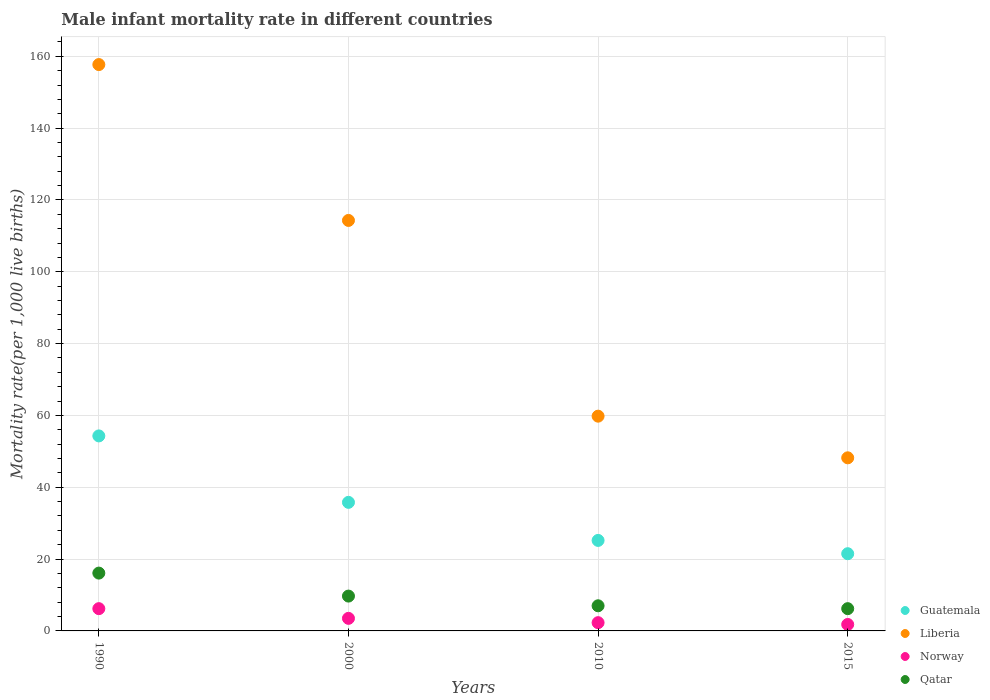How many different coloured dotlines are there?
Give a very brief answer. 4. What is the male infant mortality rate in Norway in 2015?
Your answer should be very brief. 1.8. Across all years, what is the minimum male infant mortality rate in Liberia?
Ensure brevity in your answer.  48.2. In which year was the male infant mortality rate in Guatemala maximum?
Your response must be concise. 1990. In which year was the male infant mortality rate in Liberia minimum?
Make the answer very short. 2015. What is the total male infant mortality rate in Qatar in the graph?
Your answer should be compact. 39. What is the difference between the male infant mortality rate in Qatar in 2010 and that in 2015?
Make the answer very short. 0.8. What is the difference between the male infant mortality rate in Guatemala in 2015 and the male infant mortality rate in Liberia in 2010?
Provide a short and direct response. -38.3. What is the average male infant mortality rate in Norway per year?
Provide a succinct answer. 3.45. In the year 1990, what is the difference between the male infant mortality rate in Qatar and male infant mortality rate in Norway?
Provide a short and direct response. 9.9. What is the ratio of the male infant mortality rate in Qatar in 2000 to that in 2010?
Provide a short and direct response. 1.39. Is the difference between the male infant mortality rate in Qatar in 2000 and 2015 greater than the difference between the male infant mortality rate in Norway in 2000 and 2015?
Make the answer very short. Yes. What is the difference between the highest and the second highest male infant mortality rate in Liberia?
Provide a short and direct response. 43.4. What is the difference between the highest and the lowest male infant mortality rate in Guatemala?
Keep it short and to the point. 32.8. Is the sum of the male infant mortality rate in Qatar in 1990 and 2010 greater than the maximum male infant mortality rate in Norway across all years?
Ensure brevity in your answer.  Yes. Is it the case that in every year, the sum of the male infant mortality rate in Liberia and male infant mortality rate in Qatar  is greater than the male infant mortality rate in Norway?
Your answer should be very brief. Yes. Does the male infant mortality rate in Qatar monotonically increase over the years?
Give a very brief answer. No. Is the male infant mortality rate in Norway strictly less than the male infant mortality rate in Liberia over the years?
Your answer should be very brief. Yes. How many dotlines are there?
Ensure brevity in your answer.  4. What is the difference between two consecutive major ticks on the Y-axis?
Your answer should be compact. 20. Does the graph contain grids?
Give a very brief answer. Yes. Where does the legend appear in the graph?
Ensure brevity in your answer.  Bottom right. How many legend labels are there?
Ensure brevity in your answer.  4. What is the title of the graph?
Keep it short and to the point. Male infant mortality rate in different countries. Does "Oman" appear as one of the legend labels in the graph?
Make the answer very short. No. What is the label or title of the Y-axis?
Offer a terse response. Mortality rate(per 1,0 live births). What is the Mortality rate(per 1,000 live births) of Guatemala in 1990?
Provide a succinct answer. 54.3. What is the Mortality rate(per 1,000 live births) of Liberia in 1990?
Ensure brevity in your answer.  157.7. What is the Mortality rate(per 1,000 live births) of Guatemala in 2000?
Keep it short and to the point. 35.8. What is the Mortality rate(per 1,000 live births) of Liberia in 2000?
Provide a succinct answer. 114.3. What is the Mortality rate(per 1,000 live births) in Guatemala in 2010?
Your answer should be compact. 25.2. What is the Mortality rate(per 1,000 live births) in Liberia in 2010?
Provide a short and direct response. 59.8. What is the Mortality rate(per 1,000 live births) in Norway in 2010?
Ensure brevity in your answer.  2.3. What is the Mortality rate(per 1,000 live births) of Guatemala in 2015?
Your response must be concise. 21.5. What is the Mortality rate(per 1,000 live births) of Liberia in 2015?
Make the answer very short. 48.2. Across all years, what is the maximum Mortality rate(per 1,000 live births) in Guatemala?
Provide a succinct answer. 54.3. Across all years, what is the maximum Mortality rate(per 1,000 live births) in Liberia?
Make the answer very short. 157.7. Across all years, what is the maximum Mortality rate(per 1,000 live births) in Norway?
Ensure brevity in your answer.  6.2. Across all years, what is the maximum Mortality rate(per 1,000 live births) of Qatar?
Ensure brevity in your answer.  16.1. Across all years, what is the minimum Mortality rate(per 1,000 live births) of Liberia?
Your answer should be compact. 48.2. Across all years, what is the minimum Mortality rate(per 1,000 live births) of Norway?
Offer a terse response. 1.8. What is the total Mortality rate(per 1,000 live births) in Guatemala in the graph?
Provide a succinct answer. 136.8. What is the total Mortality rate(per 1,000 live births) of Liberia in the graph?
Ensure brevity in your answer.  380. What is the total Mortality rate(per 1,000 live births) in Qatar in the graph?
Provide a succinct answer. 39. What is the difference between the Mortality rate(per 1,000 live births) in Liberia in 1990 and that in 2000?
Give a very brief answer. 43.4. What is the difference between the Mortality rate(per 1,000 live births) of Guatemala in 1990 and that in 2010?
Ensure brevity in your answer.  29.1. What is the difference between the Mortality rate(per 1,000 live births) in Liberia in 1990 and that in 2010?
Keep it short and to the point. 97.9. What is the difference between the Mortality rate(per 1,000 live births) of Norway in 1990 and that in 2010?
Your response must be concise. 3.9. What is the difference between the Mortality rate(per 1,000 live births) in Qatar in 1990 and that in 2010?
Provide a succinct answer. 9.1. What is the difference between the Mortality rate(per 1,000 live births) of Guatemala in 1990 and that in 2015?
Your response must be concise. 32.8. What is the difference between the Mortality rate(per 1,000 live births) in Liberia in 1990 and that in 2015?
Provide a succinct answer. 109.5. What is the difference between the Mortality rate(per 1,000 live births) in Liberia in 2000 and that in 2010?
Your answer should be very brief. 54.5. What is the difference between the Mortality rate(per 1,000 live births) of Norway in 2000 and that in 2010?
Your answer should be compact. 1.2. What is the difference between the Mortality rate(per 1,000 live births) in Qatar in 2000 and that in 2010?
Offer a terse response. 2.7. What is the difference between the Mortality rate(per 1,000 live births) in Guatemala in 2000 and that in 2015?
Offer a terse response. 14.3. What is the difference between the Mortality rate(per 1,000 live births) of Liberia in 2000 and that in 2015?
Make the answer very short. 66.1. What is the difference between the Mortality rate(per 1,000 live births) in Norway in 2000 and that in 2015?
Ensure brevity in your answer.  1.7. What is the difference between the Mortality rate(per 1,000 live births) of Norway in 2010 and that in 2015?
Your response must be concise. 0.5. What is the difference between the Mortality rate(per 1,000 live births) in Guatemala in 1990 and the Mortality rate(per 1,000 live births) in Liberia in 2000?
Provide a succinct answer. -60. What is the difference between the Mortality rate(per 1,000 live births) in Guatemala in 1990 and the Mortality rate(per 1,000 live births) in Norway in 2000?
Your answer should be very brief. 50.8. What is the difference between the Mortality rate(per 1,000 live births) of Guatemala in 1990 and the Mortality rate(per 1,000 live births) of Qatar in 2000?
Your answer should be very brief. 44.6. What is the difference between the Mortality rate(per 1,000 live births) in Liberia in 1990 and the Mortality rate(per 1,000 live births) in Norway in 2000?
Provide a succinct answer. 154.2. What is the difference between the Mortality rate(per 1,000 live births) of Liberia in 1990 and the Mortality rate(per 1,000 live births) of Qatar in 2000?
Offer a terse response. 148. What is the difference between the Mortality rate(per 1,000 live births) of Guatemala in 1990 and the Mortality rate(per 1,000 live births) of Liberia in 2010?
Offer a terse response. -5.5. What is the difference between the Mortality rate(per 1,000 live births) in Guatemala in 1990 and the Mortality rate(per 1,000 live births) in Norway in 2010?
Make the answer very short. 52. What is the difference between the Mortality rate(per 1,000 live births) in Guatemala in 1990 and the Mortality rate(per 1,000 live births) in Qatar in 2010?
Provide a succinct answer. 47.3. What is the difference between the Mortality rate(per 1,000 live births) in Liberia in 1990 and the Mortality rate(per 1,000 live births) in Norway in 2010?
Offer a terse response. 155.4. What is the difference between the Mortality rate(per 1,000 live births) of Liberia in 1990 and the Mortality rate(per 1,000 live births) of Qatar in 2010?
Offer a terse response. 150.7. What is the difference between the Mortality rate(per 1,000 live births) in Norway in 1990 and the Mortality rate(per 1,000 live births) in Qatar in 2010?
Make the answer very short. -0.8. What is the difference between the Mortality rate(per 1,000 live births) in Guatemala in 1990 and the Mortality rate(per 1,000 live births) in Liberia in 2015?
Offer a terse response. 6.1. What is the difference between the Mortality rate(per 1,000 live births) of Guatemala in 1990 and the Mortality rate(per 1,000 live births) of Norway in 2015?
Keep it short and to the point. 52.5. What is the difference between the Mortality rate(per 1,000 live births) in Guatemala in 1990 and the Mortality rate(per 1,000 live births) in Qatar in 2015?
Offer a terse response. 48.1. What is the difference between the Mortality rate(per 1,000 live births) of Liberia in 1990 and the Mortality rate(per 1,000 live births) of Norway in 2015?
Ensure brevity in your answer.  155.9. What is the difference between the Mortality rate(per 1,000 live births) of Liberia in 1990 and the Mortality rate(per 1,000 live births) of Qatar in 2015?
Ensure brevity in your answer.  151.5. What is the difference between the Mortality rate(per 1,000 live births) of Norway in 1990 and the Mortality rate(per 1,000 live births) of Qatar in 2015?
Your answer should be very brief. 0. What is the difference between the Mortality rate(per 1,000 live births) of Guatemala in 2000 and the Mortality rate(per 1,000 live births) of Norway in 2010?
Your response must be concise. 33.5. What is the difference between the Mortality rate(per 1,000 live births) in Guatemala in 2000 and the Mortality rate(per 1,000 live births) in Qatar in 2010?
Offer a terse response. 28.8. What is the difference between the Mortality rate(per 1,000 live births) in Liberia in 2000 and the Mortality rate(per 1,000 live births) in Norway in 2010?
Keep it short and to the point. 112. What is the difference between the Mortality rate(per 1,000 live births) of Liberia in 2000 and the Mortality rate(per 1,000 live births) of Qatar in 2010?
Keep it short and to the point. 107.3. What is the difference between the Mortality rate(per 1,000 live births) of Guatemala in 2000 and the Mortality rate(per 1,000 live births) of Norway in 2015?
Keep it short and to the point. 34. What is the difference between the Mortality rate(per 1,000 live births) of Guatemala in 2000 and the Mortality rate(per 1,000 live births) of Qatar in 2015?
Your response must be concise. 29.6. What is the difference between the Mortality rate(per 1,000 live births) in Liberia in 2000 and the Mortality rate(per 1,000 live births) in Norway in 2015?
Keep it short and to the point. 112.5. What is the difference between the Mortality rate(per 1,000 live births) in Liberia in 2000 and the Mortality rate(per 1,000 live births) in Qatar in 2015?
Your answer should be very brief. 108.1. What is the difference between the Mortality rate(per 1,000 live births) in Guatemala in 2010 and the Mortality rate(per 1,000 live births) in Norway in 2015?
Ensure brevity in your answer.  23.4. What is the difference between the Mortality rate(per 1,000 live births) in Guatemala in 2010 and the Mortality rate(per 1,000 live births) in Qatar in 2015?
Give a very brief answer. 19. What is the difference between the Mortality rate(per 1,000 live births) in Liberia in 2010 and the Mortality rate(per 1,000 live births) in Norway in 2015?
Offer a terse response. 58. What is the difference between the Mortality rate(per 1,000 live births) of Liberia in 2010 and the Mortality rate(per 1,000 live births) of Qatar in 2015?
Offer a very short reply. 53.6. What is the difference between the Mortality rate(per 1,000 live births) of Norway in 2010 and the Mortality rate(per 1,000 live births) of Qatar in 2015?
Keep it short and to the point. -3.9. What is the average Mortality rate(per 1,000 live births) of Guatemala per year?
Your answer should be very brief. 34.2. What is the average Mortality rate(per 1,000 live births) of Liberia per year?
Your answer should be compact. 95. What is the average Mortality rate(per 1,000 live births) in Norway per year?
Keep it short and to the point. 3.45. What is the average Mortality rate(per 1,000 live births) in Qatar per year?
Offer a very short reply. 9.75. In the year 1990, what is the difference between the Mortality rate(per 1,000 live births) in Guatemala and Mortality rate(per 1,000 live births) in Liberia?
Offer a terse response. -103.4. In the year 1990, what is the difference between the Mortality rate(per 1,000 live births) in Guatemala and Mortality rate(per 1,000 live births) in Norway?
Offer a terse response. 48.1. In the year 1990, what is the difference between the Mortality rate(per 1,000 live births) of Guatemala and Mortality rate(per 1,000 live births) of Qatar?
Provide a short and direct response. 38.2. In the year 1990, what is the difference between the Mortality rate(per 1,000 live births) in Liberia and Mortality rate(per 1,000 live births) in Norway?
Your response must be concise. 151.5. In the year 1990, what is the difference between the Mortality rate(per 1,000 live births) in Liberia and Mortality rate(per 1,000 live births) in Qatar?
Offer a terse response. 141.6. In the year 1990, what is the difference between the Mortality rate(per 1,000 live births) of Norway and Mortality rate(per 1,000 live births) of Qatar?
Make the answer very short. -9.9. In the year 2000, what is the difference between the Mortality rate(per 1,000 live births) of Guatemala and Mortality rate(per 1,000 live births) of Liberia?
Your response must be concise. -78.5. In the year 2000, what is the difference between the Mortality rate(per 1,000 live births) in Guatemala and Mortality rate(per 1,000 live births) in Norway?
Make the answer very short. 32.3. In the year 2000, what is the difference between the Mortality rate(per 1,000 live births) in Guatemala and Mortality rate(per 1,000 live births) in Qatar?
Make the answer very short. 26.1. In the year 2000, what is the difference between the Mortality rate(per 1,000 live births) in Liberia and Mortality rate(per 1,000 live births) in Norway?
Give a very brief answer. 110.8. In the year 2000, what is the difference between the Mortality rate(per 1,000 live births) in Liberia and Mortality rate(per 1,000 live births) in Qatar?
Offer a terse response. 104.6. In the year 2000, what is the difference between the Mortality rate(per 1,000 live births) of Norway and Mortality rate(per 1,000 live births) of Qatar?
Your response must be concise. -6.2. In the year 2010, what is the difference between the Mortality rate(per 1,000 live births) of Guatemala and Mortality rate(per 1,000 live births) of Liberia?
Your answer should be compact. -34.6. In the year 2010, what is the difference between the Mortality rate(per 1,000 live births) of Guatemala and Mortality rate(per 1,000 live births) of Norway?
Keep it short and to the point. 22.9. In the year 2010, what is the difference between the Mortality rate(per 1,000 live births) of Guatemala and Mortality rate(per 1,000 live births) of Qatar?
Your response must be concise. 18.2. In the year 2010, what is the difference between the Mortality rate(per 1,000 live births) of Liberia and Mortality rate(per 1,000 live births) of Norway?
Give a very brief answer. 57.5. In the year 2010, what is the difference between the Mortality rate(per 1,000 live births) of Liberia and Mortality rate(per 1,000 live births) of Qatar?
Provide a succinct answer. 52.8. In the year 2015, what is the difference between the Mortality rate(per 1,000 live births) in Guatemala and Mortality rate(per 1,000 live births) in Liberia?
Keep it short and to the point. -26.7. In the year 2015, what is the difference between the Mortality rate(per 1,000 live births) in Guatemala and Mortality rate(per 1,000 live births) in Norway?
Your answer should be compact. 19.7. In the year 2015, what is the difference between the Mortality rate(per 1,000 live births) of Liberia and Mortality rate(per 1,000 live births) of Norway?
Provide a short and direct response. 46.4. In the year 2015, what is the difference between the Mortality rate(per 1,000 live births) of Norway and Mortality rate(per 1,000 live births) of Qatar?
Offer a terse response. -4.4. What is the ratio of the Mortality rate(per 1,000 live births) in Guatemala in 1990 to that in 2000?
Offer a terse response. 1.52. What is the ratio of the Mortality rate(per 1,000 live births) of Liberia in 1990 to that in 2000?
Your answer should be very brief. 1.38. What is the ratio of the Mortality rate(per 1,000 live births) of Norway in 1990 to that in 2000?
Your answer should be compact. 1.77. What is the ratio of the Mortality rate(per 1,000 live births) of Qatar in 1990 to that in 2000?
Your answer should be very brief. 1.66. What is the ratio of the Mortality rate(per 1,000 live births) of Guatemala in 1990 to that in 2010?
Your answer should be compact. 2.15. What is the ratio of the Mortality rate(per 1,000 live births) in Liberia in 1990 to that in 2010?
Provide a succinct answer. 2.64. What is the ratio of the Mortality rate(per 1,000 live births) of Norway in 1990 to that in 2010?
Give a very brief answer. 2.7. What is the ratio of the Mortality rate(per 1,000 live births) of Qatar in 1990 to that in 2010?
Offer a terse response. 2.3. What is the ratio of the Mortality rate(per 1,000 live births) in Guatemala in 1990 to that in 2015?
Give a very brief answer. 2.53. What is the ratio of the Mortality rate(per 1,000 live births) in Liberia in 1990 to that in 2015?
Your response must be concise. 3.27. What is the ratio of the Mortality rate(per 1,000 live births) in Norway in 1990 to that in 2015?
Offer a very short reply. 3.44. What is the ratio of the Mortality rate(per 1,000 live births) in Qatar in 1990 to that in 2015?
Offer a very short reply. 2.6. What is the ratio of the Mortality rate(per 1,000 live births) in Guatemala in 2000 to that in 2010?
Give a very brief answer. 1.42. What is the ratio of the Mortality rate(per 1,000 live births) of Liberia in 2000 to that in 2010?
Keep it short and to the point. 1.91. What is the ratio of the Mortality rate(per 1,000 live births) in Norway in 2000 to that in 2010?
Offer a very short reply. 1.52. What is the ratio of the Mortality rate(per 1,000 live births) in Qatar in 2000 to that in 2010?
Provide a short and direct response. 1.39. What is the ratio of the Mortality rate(per 1,000 live births) in Guatemala in 2000 to that in 2015?
Ensure brevity in your answer.  1.67. What is the ratio of the Mortality rate(per 1,000 live births) of Liberia in 2000 to that in 2015?
Offer a terse response. 2.37. What is the ratio of the Mortality rate(per 1,000 live births) in Norway in 2000 to that in 2015?
Provide a succinct answer. 1.94. What is the ratio of the Mortality rate(per 1,000 live births) in Qatar in 2000 to that in 2015?
Offer a terse response. 1.56. What is the ratio of the Mortality rate(per 1,000 live births) of Guatemala in 2010 to that in 2015?
Make the answer very short. 1.17. What is the ratio of the Mortality rate(per 1,000 live births) of Liberia in 2010 to that in 2015?
Your answer should be compact. 1.24. What is the ratio of the Mortality rate(per 1,000 live births) in Norway in 2010 to that in 2015?
Offer a very short reply. 1.28. What is the ratio of the Mortality rate(per 1,000 live births) in Qatar in 2010 to that in 2015?
Provide a short and direct response. 1.13. What is the difference between the highest and the second highest Mortality rate(per 1,000 live births) in Guatemala?
Provide a succinct answer. 18.5. What is the difference between the highest and the second highest Mortality rate(per 1,000 live births) in Liberia?
Your answer should be very brief. 43.4. What is the difference between the highest and the second highest Mortality rate(per 1,000 live births) in Norway?
Your answer should be very brief. 2.7. What is the difference between the highest and the second highest Mortality rate(per 1,000 live births) in Qatar?
Ensure brevity in your answer.  6.4. What is the difference between the highest and the lowest Mortality rate(per 1,000 live births) in Guatemala?
Provide a short and direct response. 32.8. What is the difference between the highest and the lowest Mortality rate(per 1,000 live births) in Liberia?
Your response must be concise. 109.5. What is the difference between the highest and the lowest Mortality rate(per 1,000 live births) of Norway?
Provide a short and direct response. 4.4. 